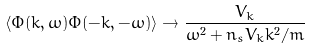Convert formula to latex. <formula><loc_0><loc_0><loc_500><loc_500>\left \langle \Phi ( { k } , \omega ) \Phi ( - { k } , - \omega ) \right \rangle \rightarrow \frac { V _ { k } } { \omega ^ { 2 } + n _ { s } V _ { k } k ^ { 2 } / m }</formula> 